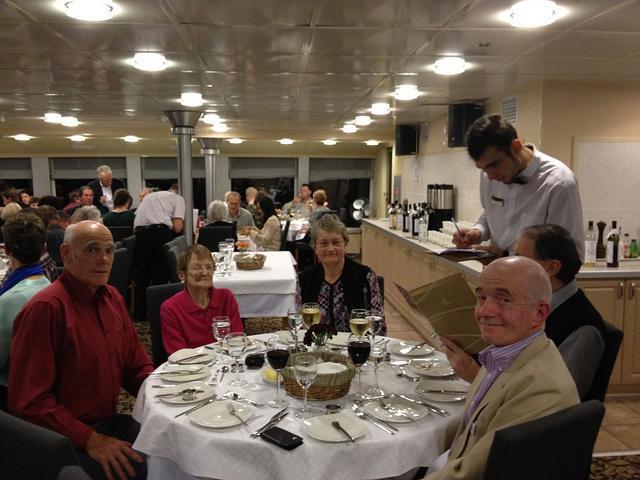How many dining tables are there?
Give a very brief answer. 2. How many chairs are visible?
Give a very brief answer. 2. How many people are there?
Give a very brief answer. 9. 